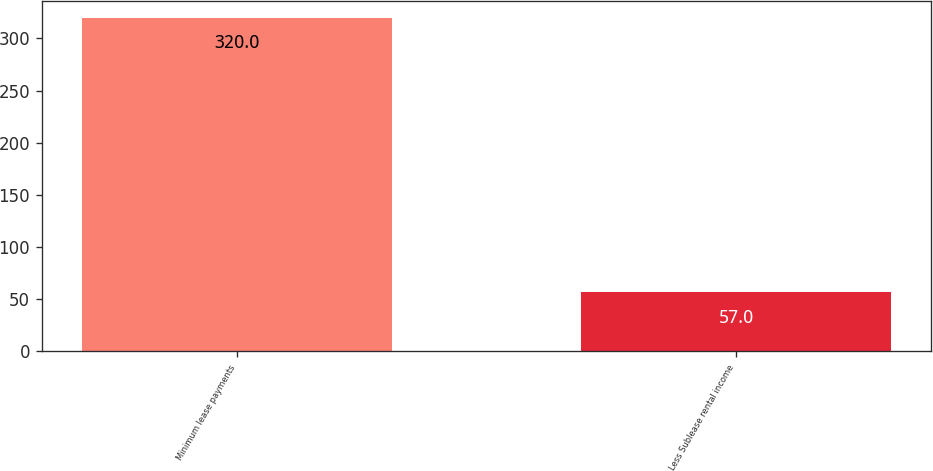Convert chart to OTSL. <chart><loc_0><loc_0><loc_500><loc_500><bar_chart><fcel>Minimum lease payments<fcel>Less Sublease rental income<nl><fcel>320<fcel>57<nl></chart> 